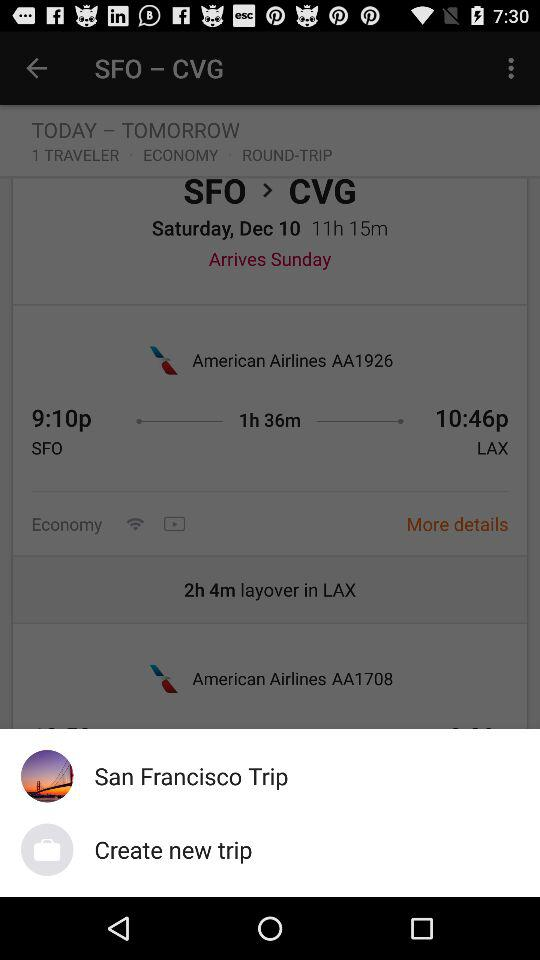What is the flight duration from SFO to CVG? The flight duration from SFO to CVG is 11 hours and 15 minutes. 